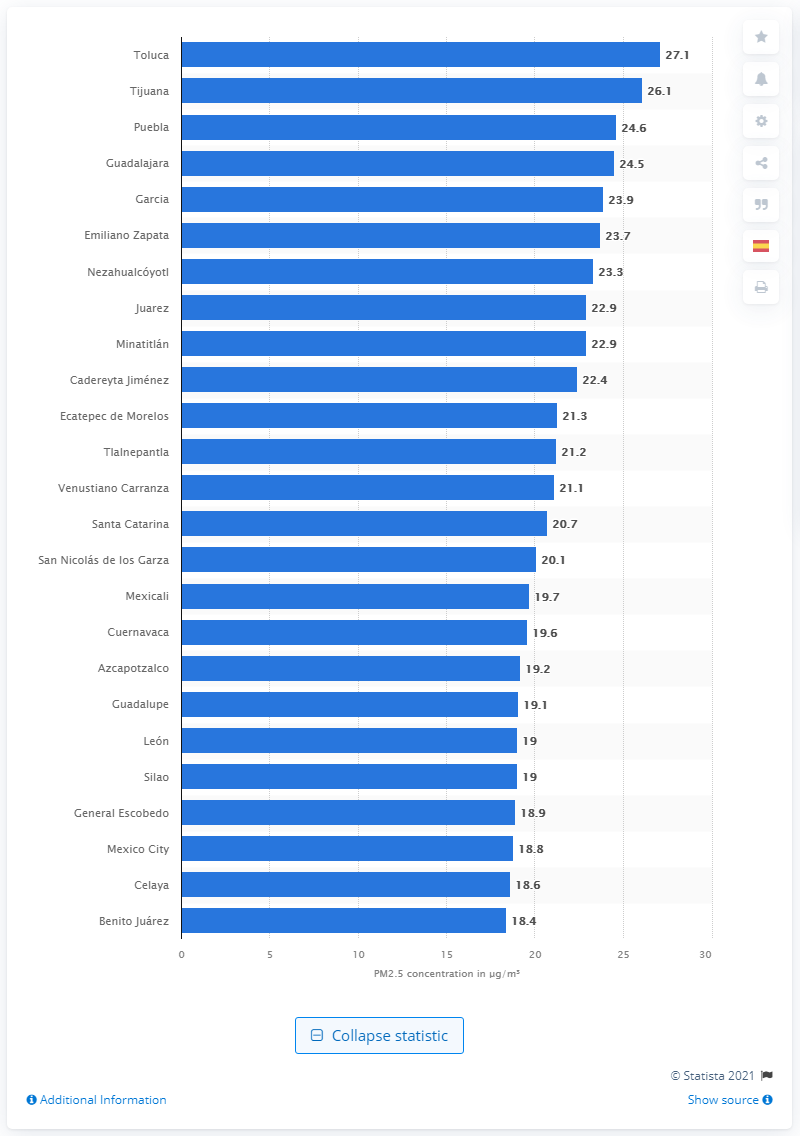Draw attention to some important aspects in this diagram. The most polluted city in the country in 2020 was Toluca. 